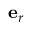<formula> <loc_0><loc_0><loc_500><loc_500>{ e } _ { r }</formula> 